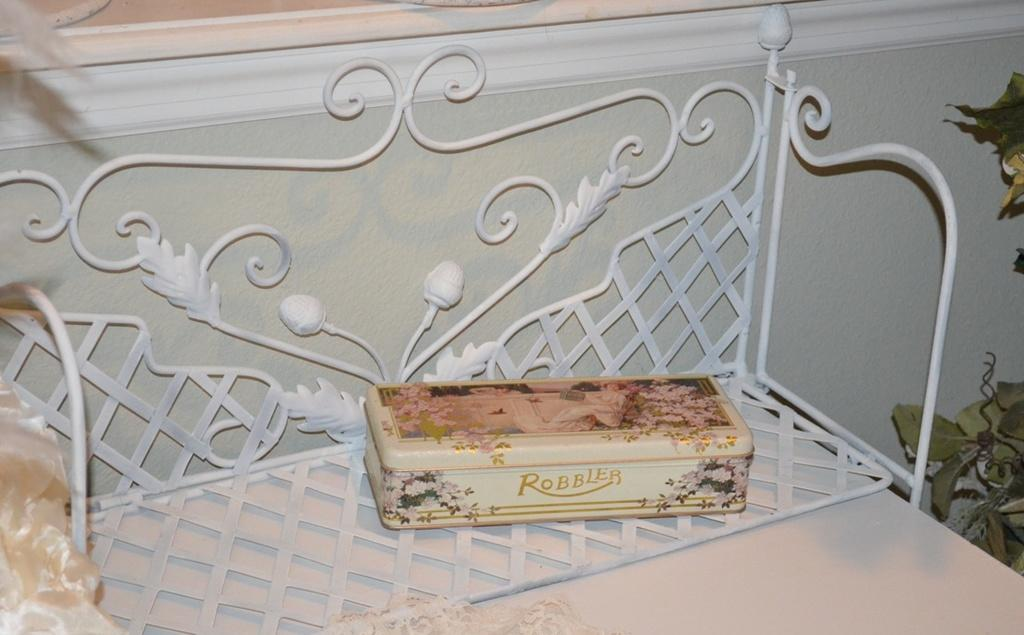What is the color of the box in the image? The box in the image is cream-colored. Where is the box located in the image? The box is on an iron rack. What is the color of the wall in the image? The wall in the image is white-colored. What type of vegetation can be seen in the image? Trees are visible in the image. What type of frame is visible around the trees in the image? There is no frame visible around the trees in the image. 